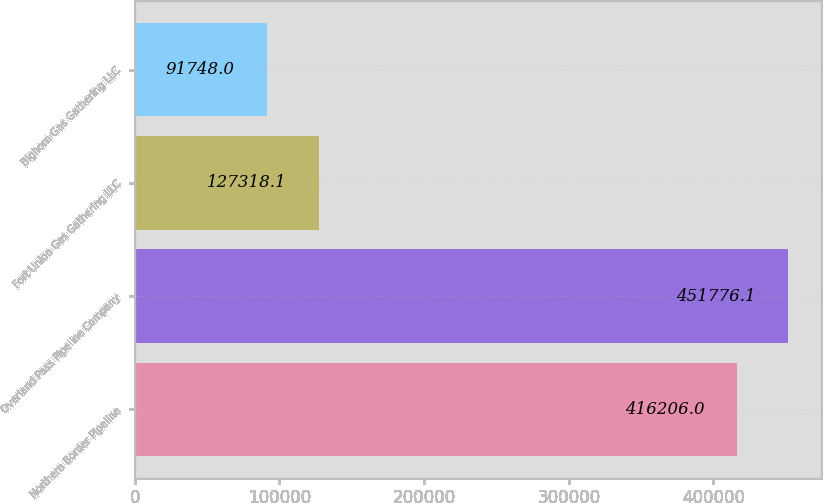Convert chart to OTSL. <chart><loc_0><loc_0><loc_500><loc_500><bar_chart><fcel>Northern Border Pipeline<fcel>Overland Pass Pipeline Company<fcel>Fort Union Gas Gathering LLC<fcel>Bighorn Gas Gathering LLC<nl><fcel>416206<fcel>451776<fcel>127318<fcel>91748<nl></chart> 